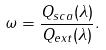<formula> <loc_0><loc_0><loc_500><loc_500>\omega = \frac { Q _ { s c a } ( \lambda ) } { Q _ { e x t } ( \lambda ) } .</formula> 